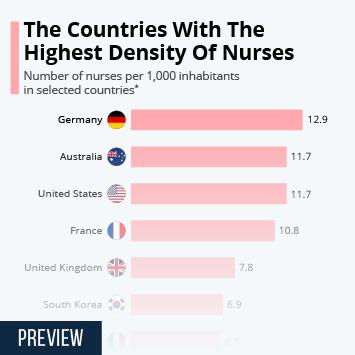Outline some significant characteristics in this image. Australia shares the second highest density of nurses per 1,000 inhabitants along with the United States. The United Kingdom has the fourth highest density of nurses per 1,000 inhabitants, according to recent data. Australia and the United States have the second highest density of nurses per 1,000 inhabitants, according to recent data. France has the third highest density of nurses per 1,000 inhabitants among all countries. According to data, Germany has the highest density of nurses per 1,000 inhabitants among all countries. 